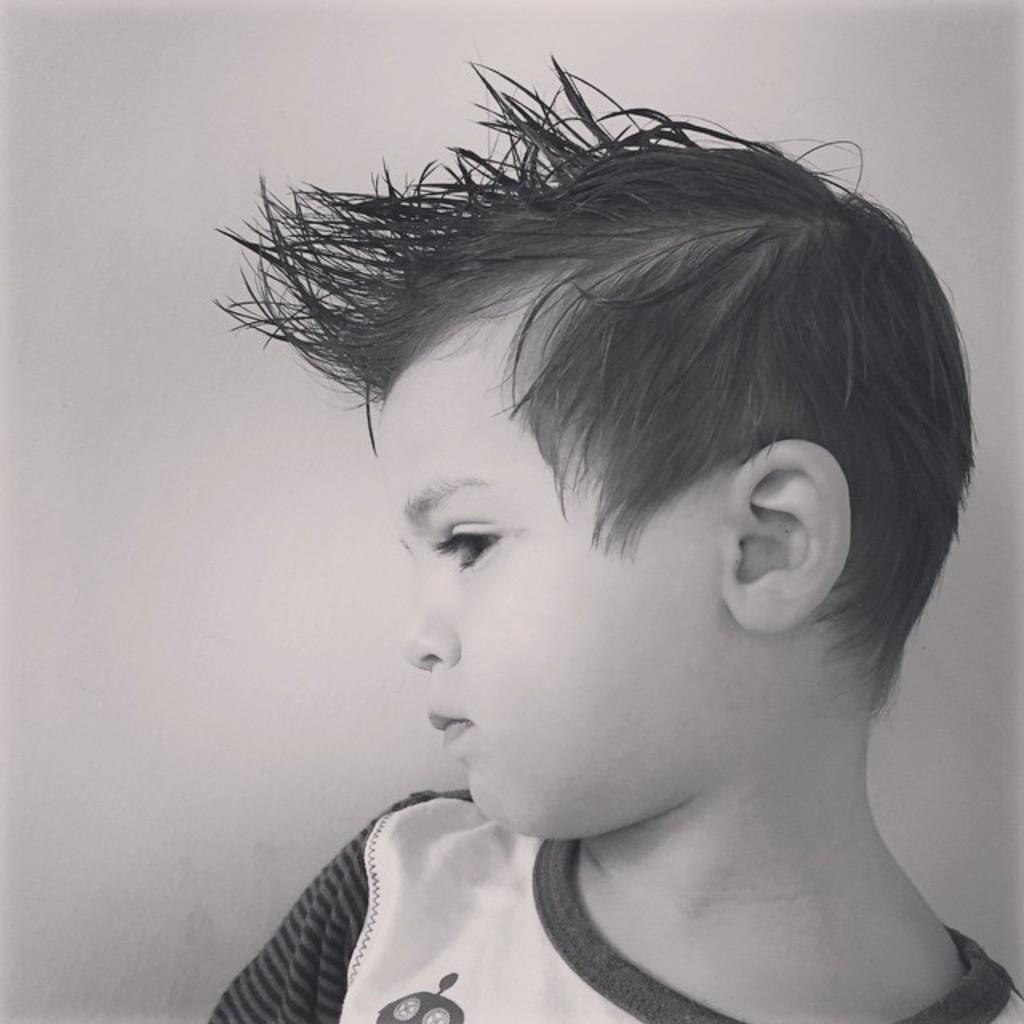What is the color scheme of the image? The image is black and white. Who or what is the main subject in the image? There is a boy in the image. What can be seen in the background of the image? There is a wall in the background of the image. What type of van is parked next to the boy in the image? There is no van present in the image; it only features a boy and a wall in the background. Can you describe the dog that is attacking the boy in the image? There is no dog or attack depicted in the image; it only features a boy and a wall in the background. 